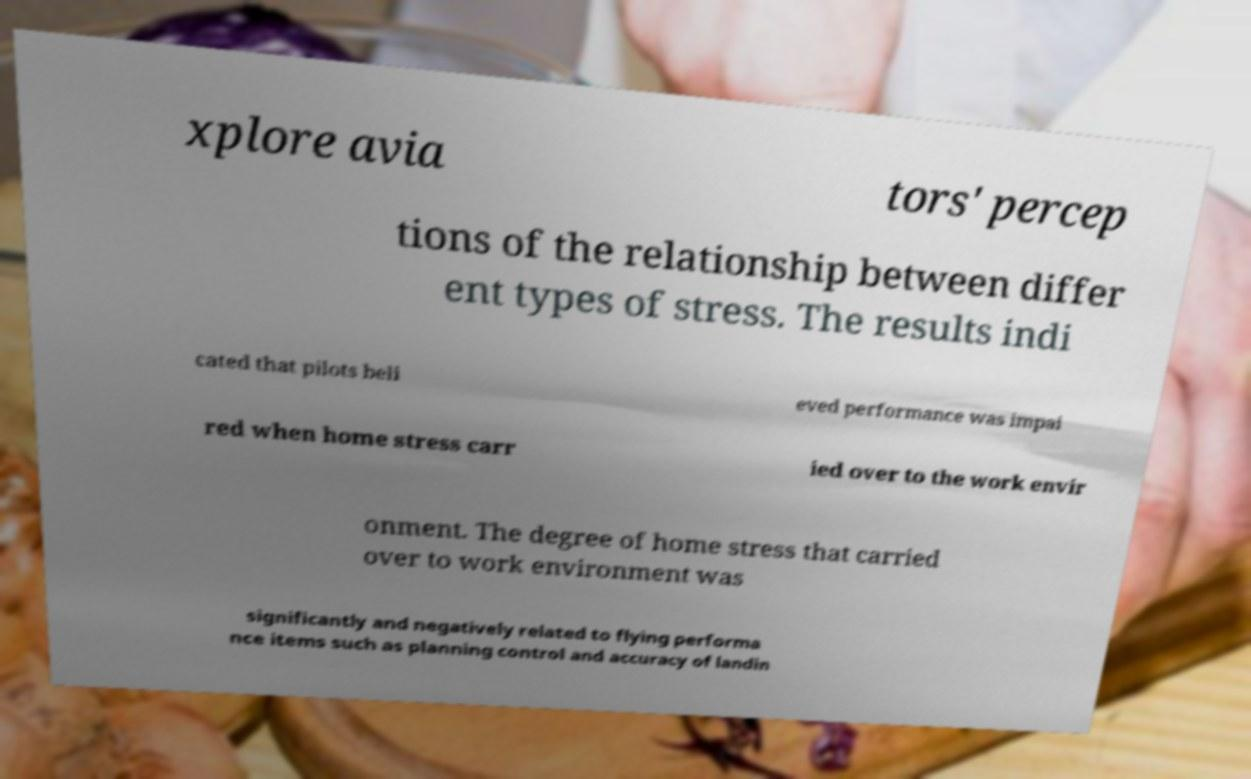Can you read and provide the text displayed in the image?This photo seems to have some interesting text. Can you extract and type it out for me? xplore avia tors' percep tions of the relationship between differ ent types of stress. The results indi cated that pilots beli eved performance was impai red when home stress carr ied over to the work envir onment. The degree of home stress that carried over to work environment was significantly and negatively related to flying performa nce items such as planning control and accuracy of landin 